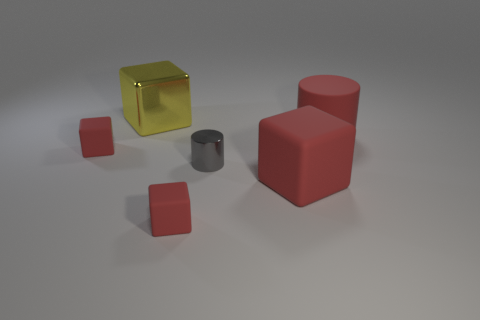Subtract all red blocks. How many were subtracted if there are1red blocks left? 2 Subtract all green balls. How many red blocks are left? 3 Subtract all red rubber blocks. How many blocks are left? 1 Subtract 2 cubes. How many cubes are left? 2 Subtract all yellow cubes. How many cubes are left? 3 Subtract all cyan cubes. Subtract all blue spheres. How many cubes are left? 4 Add 1 red cylinders. How many objects exist? 7 Subtract all blocks. How many objects are left? 2 Subtract all red cylinders. Subtract all large green metal things. How many objects are left? 5 Add 5 cylinders. How many cylinders are left? 7 